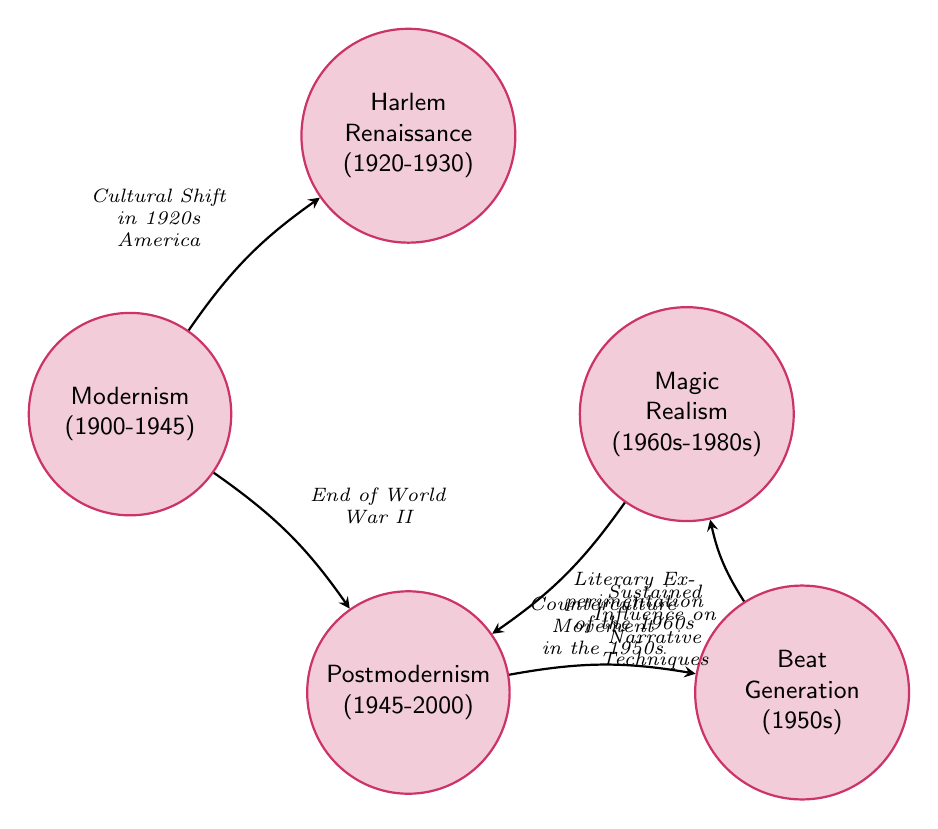What is the time period of Modernism? The diagram shows that Modernism spans from 1900 to 1945, indicated in the node description.
Answer: 1900-1945 Which node has a transition from Modernism? From the diagram, we can see that Modernism transitions to both Harlem Renaissance and Postmodernism, as indicated by the arrows leading from the Modernism node.
Answer: Harlem Renaissance, Postmodernism What cultural condition led to the Harlem Renaissance? The arrow from Modernism to Harlem Renaissance is labeled "Cultural Shift in 1920s America," which specifies the condition that prompted this transition.
Answer: Cultural Shift in 1920s America How many nodes are depicted in this diagram? By counting the nodes shown in the diagram, we can identify that there are five states: Modernism, Harlem Renaissance, Postmodernism, Beat Generation, and Magic Realism.
Answer: 5 What follows the Beat Generation according to the diagram? The transition from Beat Generation leads to Magic Realism based on the arrow and the description along the path in the diagram.
Answer: Magic Realism What is the relationship between Magic Realism and Postmodernism? The diagram displays an arrow going from Magic Realism back to Postmodernism, labelled "Sustained Influence on Narrative Techniques," indicating a looping relationship between these two literature movements.
Answer: Sustained Influence on Narrative Techniques Which literary movement emerged after the end of World War II? The diagram states that the transition from Modernism to Postmodernism was prompted by the "End of World War II," indicating that Postmodernism followed this major historical event.
Answer: Postmodernism What thematic focus does the Beat Generation emphasize? The description in the node for the Beat Generation explicitly mentions exploring themes of "spiritual liberation, anti-conformity, and spontaneous creativity," which captures its core focus.
Answer: Spiritual liberation, anti-conformity, and spontaneous creativity 